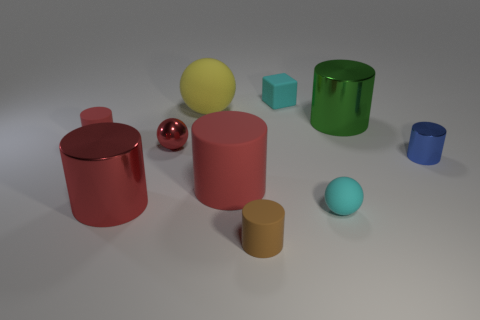Is there a color theme or pattern visible among the objects? The objects in the image collectively display a variety of colors with no apparent pattern or theme. The colors range from warm to cool tones, and their placement appears to be random, contributing to a visually diverse and colorful scene. 